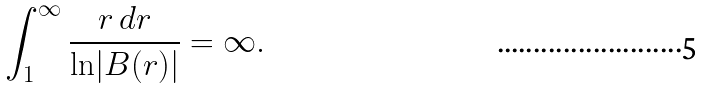Convert formula to latex. <formula><loc_0><loc_0><loc_500><loc_500>\int _ { 1 } ^ { \infty } \frac { r \, d r } { { \ln } | B ( r ) | } = \infty .</formula> 